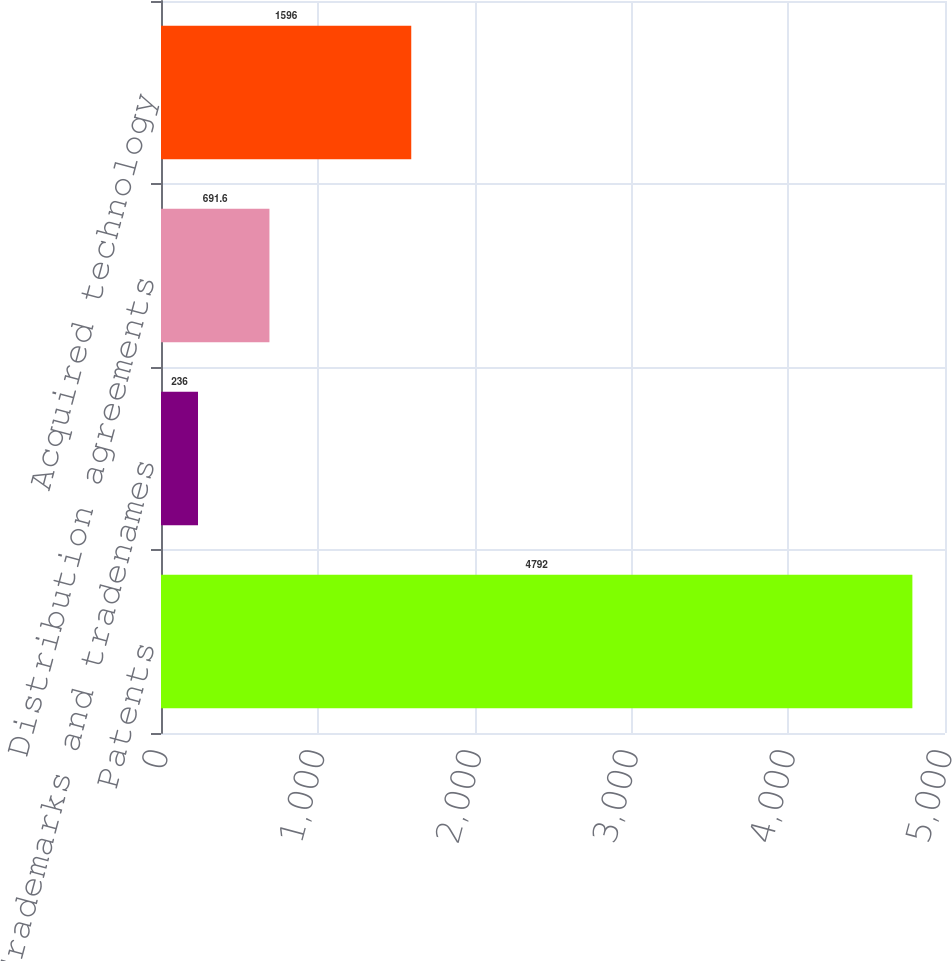<chart> <loc_0><loc_0><loc_500><loc_500><bar_chart><fcel>Patents<fcel>Trademarks and tradenames<fcel>Distribution agreements<fcel>Acquired technology<nl><fcel>4792<fcel>236<fcel>691.6<fcel>1596<nl></chart> 